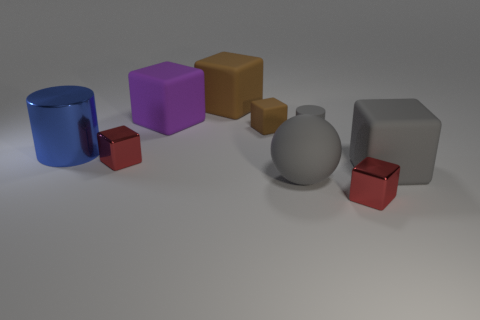There is a matte ball that is the same color as the small cylinder; what size is it?
Your answer should be compact. Large. What number of big brown objects are the same shape as the large purple thing?
Make the answer very short. 1. The big matte cube that is behind the large purple object is what color?
Your response must be concise. Brown. What number of metal things are big cylinders or small red balls?
Provide a short and direct response. 1. What shape is the rubber object that is the same color as the small rubber block?
Give a very brief answer. Cube. What number of gray matte blocks are the same size as the purple matte thing?
Keep it short and to the point. 1. The big object that is both to the left of the large brown matte cube and to the right of the big blue cylinder is what color?
Your answer should be very brief. Purple. How many objects are red shiny blocks or blue objects?
Your answer should be very brief. 3. What number of small objects are gray matte cylinders or gray blocks?
Provide a succinct answer. 1. Are there any other things that are the same color as the small matte block?
Offer a very short reply. Yes. 